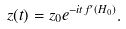<formula> <loc_0><loc_0><loc_500><loc_500>z ( t ) = z _ { 0 } e ^ { - i t f ^ { \prime } ( H _ { 0 } ) } .</formula> 